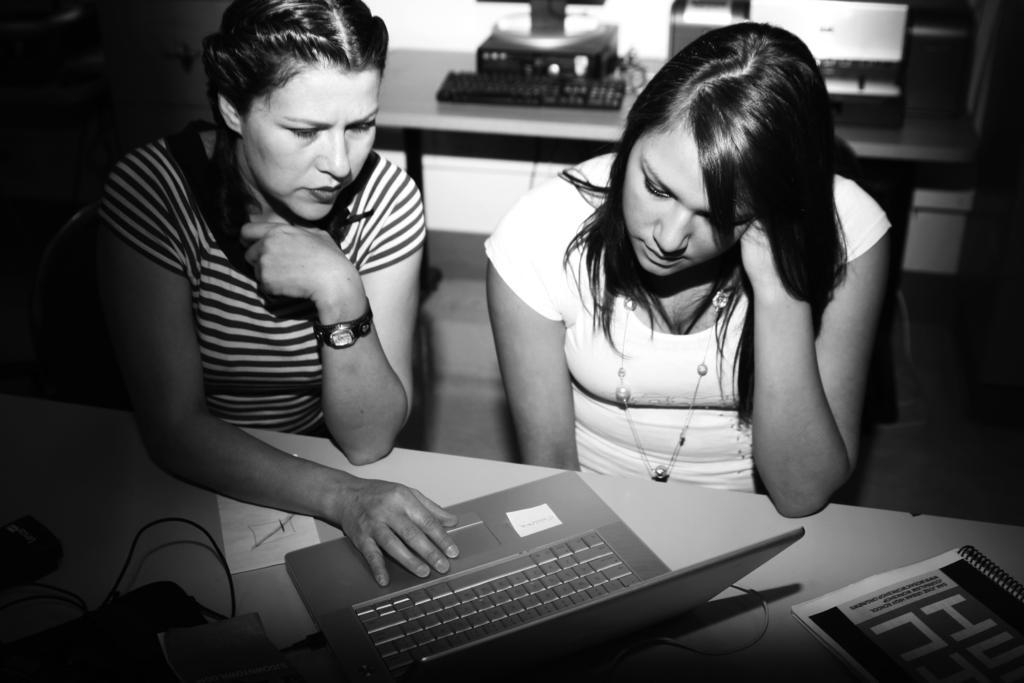How would you summarize this image in a sentence or two? In this image there are two people sitting. There are chairs and tables. There is laptop. We can see file. In the background we can see monitor, cpu and keyboard. 